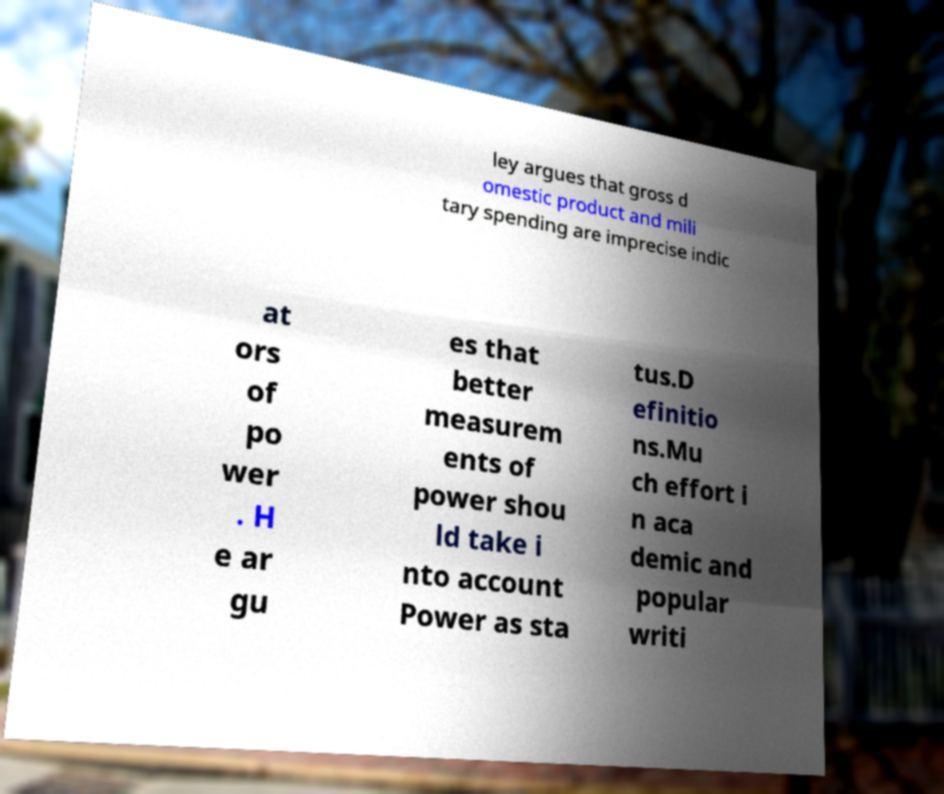Could you extract and type out the text from this image? ley argues that gross d omestic product and mili tary spending are imprecise indic at ors of po wer . H e ar gu es that better measurem ents of power shou ld take i nto account Power as sta tus.D efinitio ns.Mu ch effort i n aca demic and popular writi 